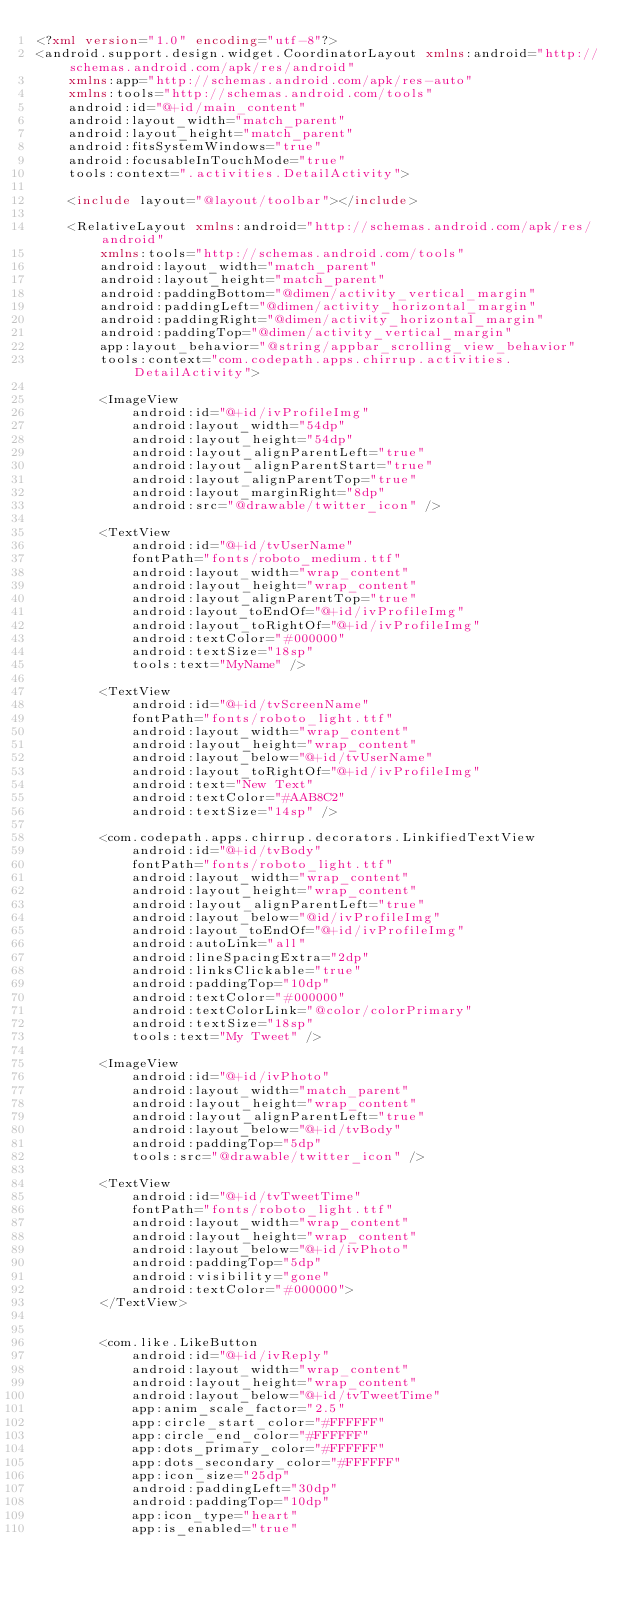<code> <loc_0><loc_0><loc_500><loc_500><_XML_><?xml version="1.0" encoding="utf-8"?>
<android.support.design.widget.CoordinatorLayout xmlns:android="http://schemas.android.com/apk/res/android"
    xmlns:app="http://schemas.android.com/apk/res-auto"
    xmlns:tools="http://schemas.android.com/tools"
    android:id="@+id/main_content"
    android:layout_width="match_parent"
    android:layout_height="match_parent"
    android:fitsSystemWindows="true"
    android:focusableInTouchMode="true"
    tools:context=".activities.DetailActivity">

    <include layout="@layout/toolbar"></include>

    <RelativeLayout xmlns:android="http://schemas.android.com/apk/res/android"
        xmlns:tools="http://schemas.android.com/tools"
        android:layout_width="match_parent"
        android:layout_height="match_parent"
        android:paddingBottom="@dimen/activity_vertical_margin"
        android:paddingLeft="@dimen/activity_horizontal_margin"
        android:paddingRight="@dimen/activity_horizontal_margin"
        android:paddingTop="@dimen/activity_vertical_margin"
        app:layout_behavior="@string/appbar_scrolling_view_behavior"
        tools:context="com.codepath.apps.chirrup.activities.DetailActivity">

        <ImageView
            android:id="@+id/ivProfileImg"
            android:layout_width="54dp"
            android:layout_height="54dp"
            android:layout_alignParentLeft="true"
            android:layout_alignParentStart="true"
            android:layout_alignParentTop="true"
            android:layout_marginRight="8dp"
            android:src="@drawable/twitter_icon" />

        <TextView
            android:id="@+id/tvUserName"
            fontPath="fonts/roboto_medium.ttf"
            android:layout_width="wrap_content"
            android:layout_height="wrap_content"
            android:layout_alignParentTop="true"
            android:layout_toEndOf="@+id/ivProfileImg"
            android:layout_toRightOf="@+id/ivProfileImg"
            android:textColor="#000000"
            android:textSize="18sp"
            tools:text="MyName" />

        <TextView
            android:id="@+id/tvScreenName"
            fontPath="fonts/roboto_light.ttf"
            android:layout_width="wrap_content"
            android:layout_height="wrap_content"
            android:layout_below="@+id/tvUserName"
            android:layout_toRightOf="@+id/ivProfileImg"
            android:text="New Text"
            android:textColor="#AAB8C2"
            android:textSize="14sp" />

        <com.codepath.apps.chirrup.decorators.LinkifiedTextView
            android:id="@+id/tvBody"
            fontPath="fonts/roboto_light.ttf"
            android:layout_width="wrap_content"
            android:layout_height="wrap_content"
            android:layout_alignParentLeft="true"
            android:layout_below="@id/ivProfileImg"
            android:layout_toEndOf="@+id/ivProfileImg"
            android:autoLink="all"
            android:lineSpacingExtra="2dp"
            android:linksClickable="true"
            android:paddingTop="10dp"
            android:textColor="#000000"
            android:textColorLink="@color/colorPrimary"
            android:textSize="18sp"
            tools:text="My Tweet" />

        <ImageView
            android:id="@+id/ivPhoto"
            android:layout_width="match_parent"
            android:layout_height="wrap_content"
            android:layout_alignParentLeft="true"
            android:layout_below="@+id/tvBody"
            android:paddingTop="5dp"
            tools:src="@drawable/twitter_icon" />

        <TextView
            android:id="@+id/tvTweetTime"
            fontPath="fonts/roboto_light.ttf"
            android:layout_width="wrap_content"
            android:layout_height="wrap_content"
            android:layout_below="@+id/ivPhoto"
            android:paddingTop="5dp"
            android:visibility="gone"
            android:textColor="#000000">
        </TextView>


        <com.like.LikeButton
            android:id="@+id/ivReply"
            android:layout_width="wrap_content"
            android:layout_height="wrap_content"
            android:layout_below="@+id/tvTweetTime"
            app:anim_scale_factor="2.5"
            app:circle_start_color="#FFFFFF"
            app:circle_end_color="#FFFFFF"
            app:dots_primary_color="#FFFFFF"
            app:dots_secondary_color="#FFFFFF"
            app:icon_size="25dp"
            android:paddingLeft="30dp"
            android:paddingTop="10dp"
            app:icon_type="heart"
            app:is_enabled="true"</code> 